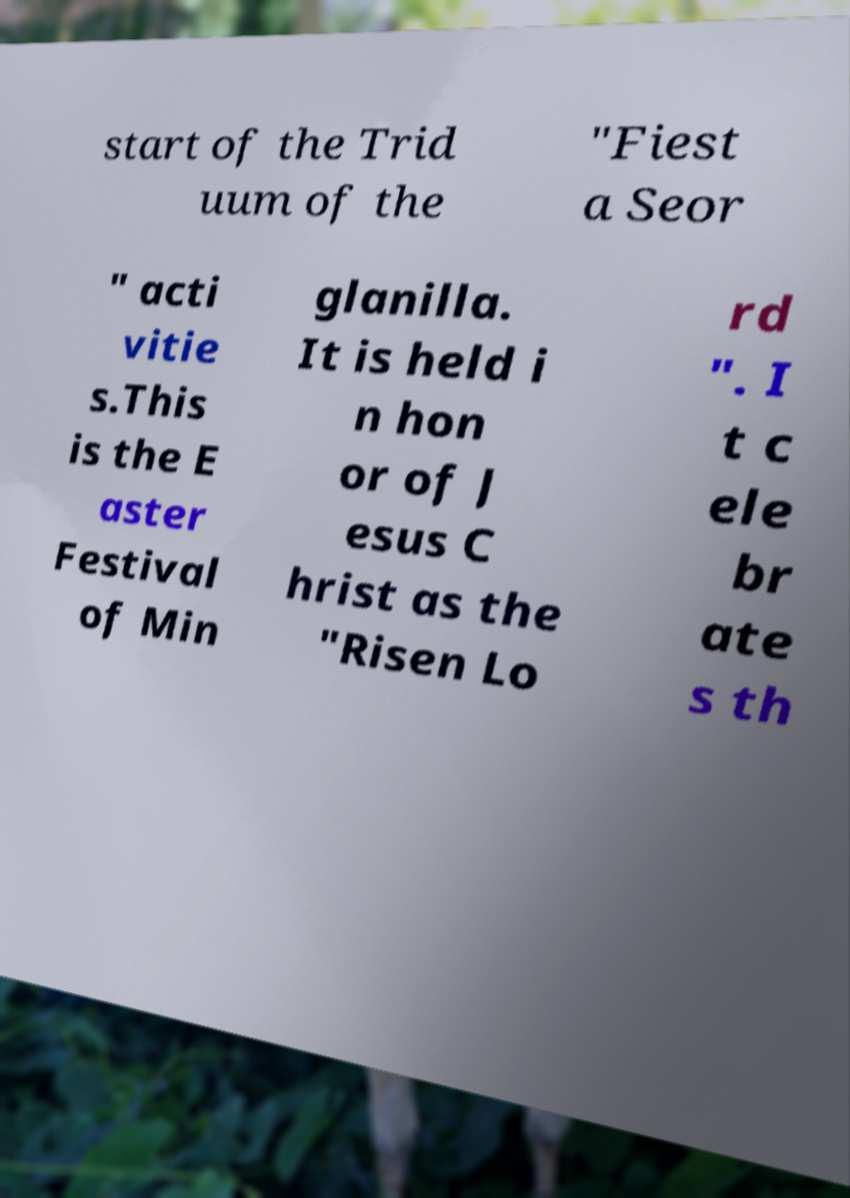What messages or text are displayed in this image? I need them in a readable, typed format. start of the Trid uum of the "Fiest a Seor " acti vitie s.This is the E aster Festival of Min glanilla. It is held i n hon or of J esus C hrist as the "Risen Lo rd ". I t c ele br ate s th 